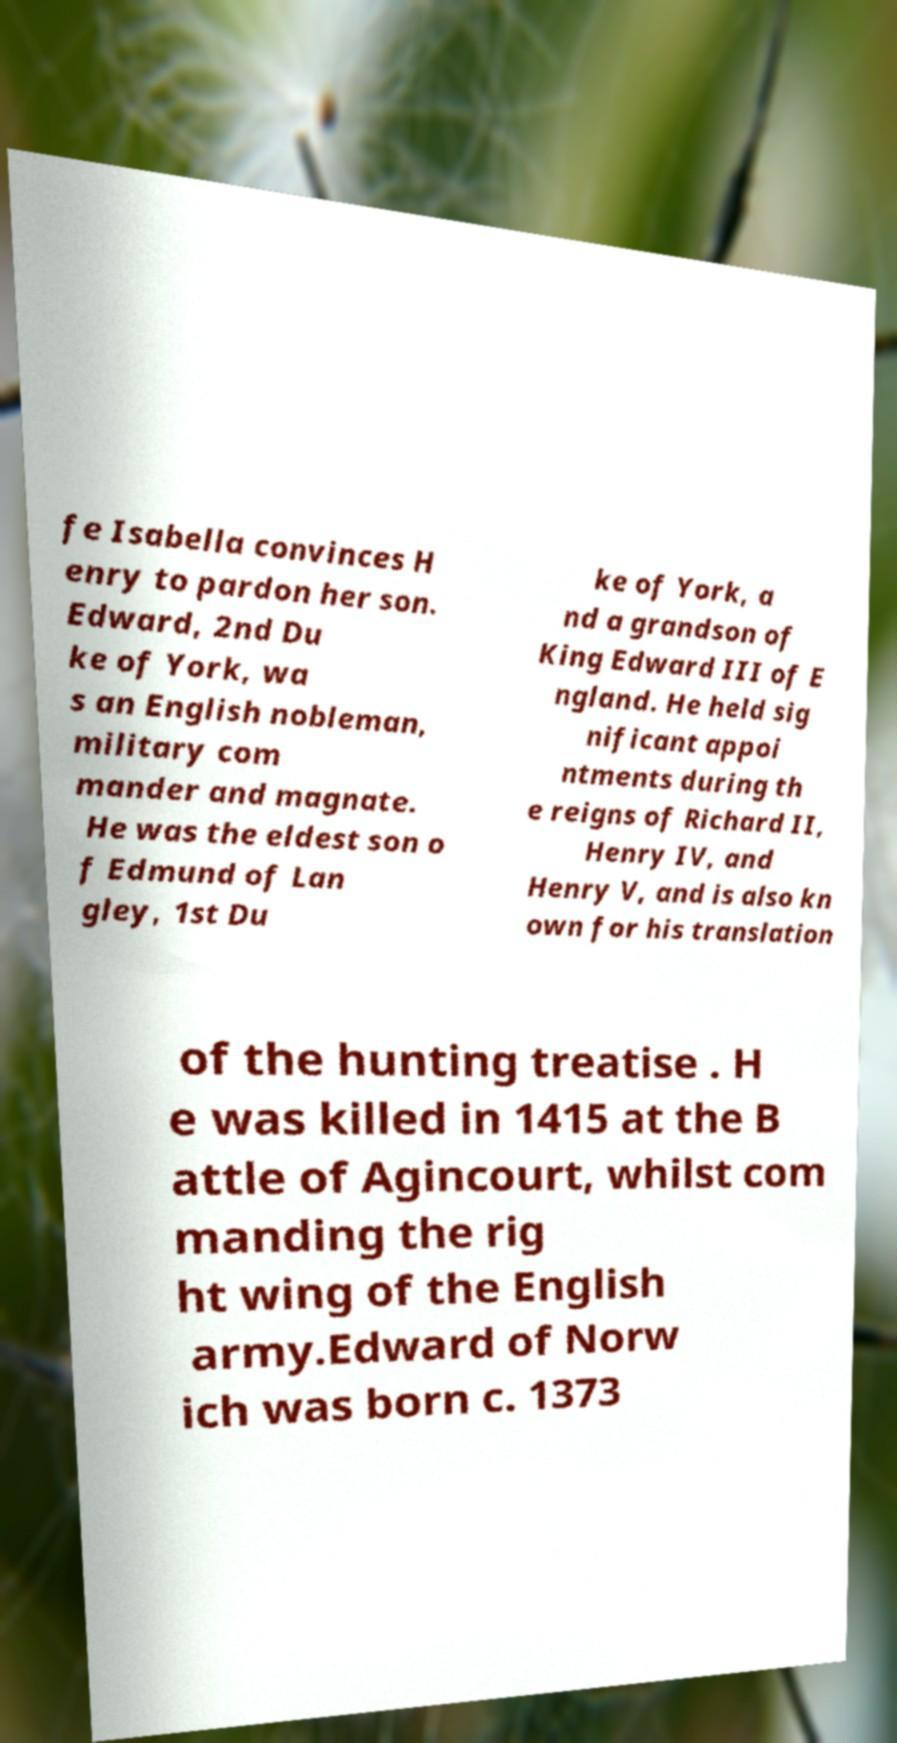Can you accurately transcribe the text from the provided image for me? fe Isabella convinces H enry to pardon her son. Edward, 2nd Du ke of York, wa s an English nobleman, military com mander and magnate. He was the eldest son o f Edmund of Lan gley, 1st Du ke of York, a nd a grandson of King Edward III of E ngland. He held sig nificant appoi ntments during th e reigns of Richard II, Henry IV, and Henry V, and is also kn own for his translation of the hunting treatise . H e was killed in 1415 at the B attle of Agincourt, whilst com manding the rig ht wing of the English army.Edward of Norw ich was born c. 1373 